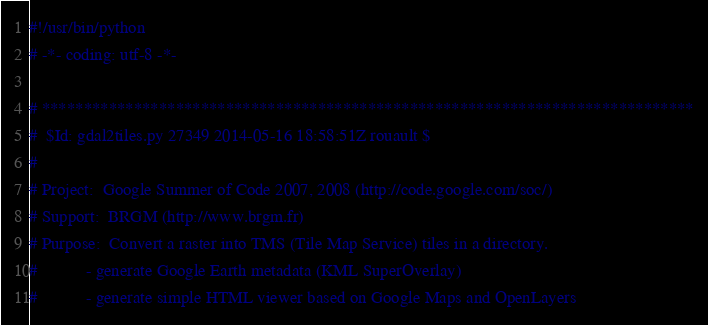<code> <loc_0><loc_0><loc_500><loc_500><_Python_>#!/usr/bin/python
# -*- coding: utf-8 -*-

# ******************************************************************************
#  $Id: gdal2tiles.py 27349 2014-05-16 18:58:51Z rouault $
#
# Project:  Google Summer of Code 2007, 2008 (http://code.google.com/soc/)
# Support:  BRGM (http://www.brgm.fr)
# Purpose:  Convert a raster into TMS (Tile Map Service) tiles in a directory.
#           - generate Google Earth metadata (KML SuperOverlay)
#           - generate simple HTML viewer based on Google Maps and OpenLayers</code> 